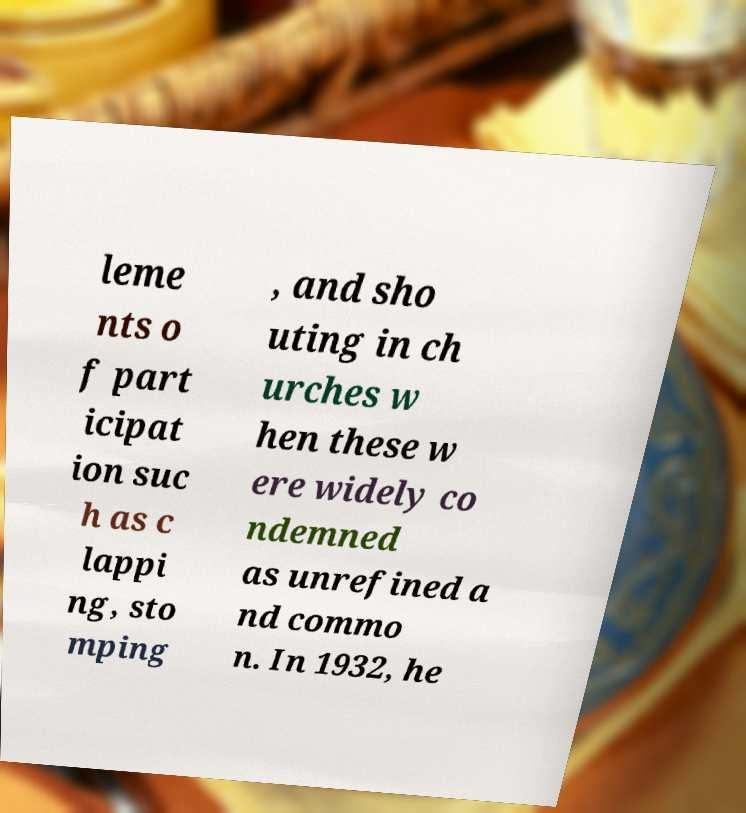For documentation purposes, I need the text within this image transcribed. Could you provide that? leme nts o f part icipat ion suc h as c lappi ng, sto mping , and sho uting in ch urches w hen these w ere widely co ndemned as unrefined a nd commo n. In 1932, he 